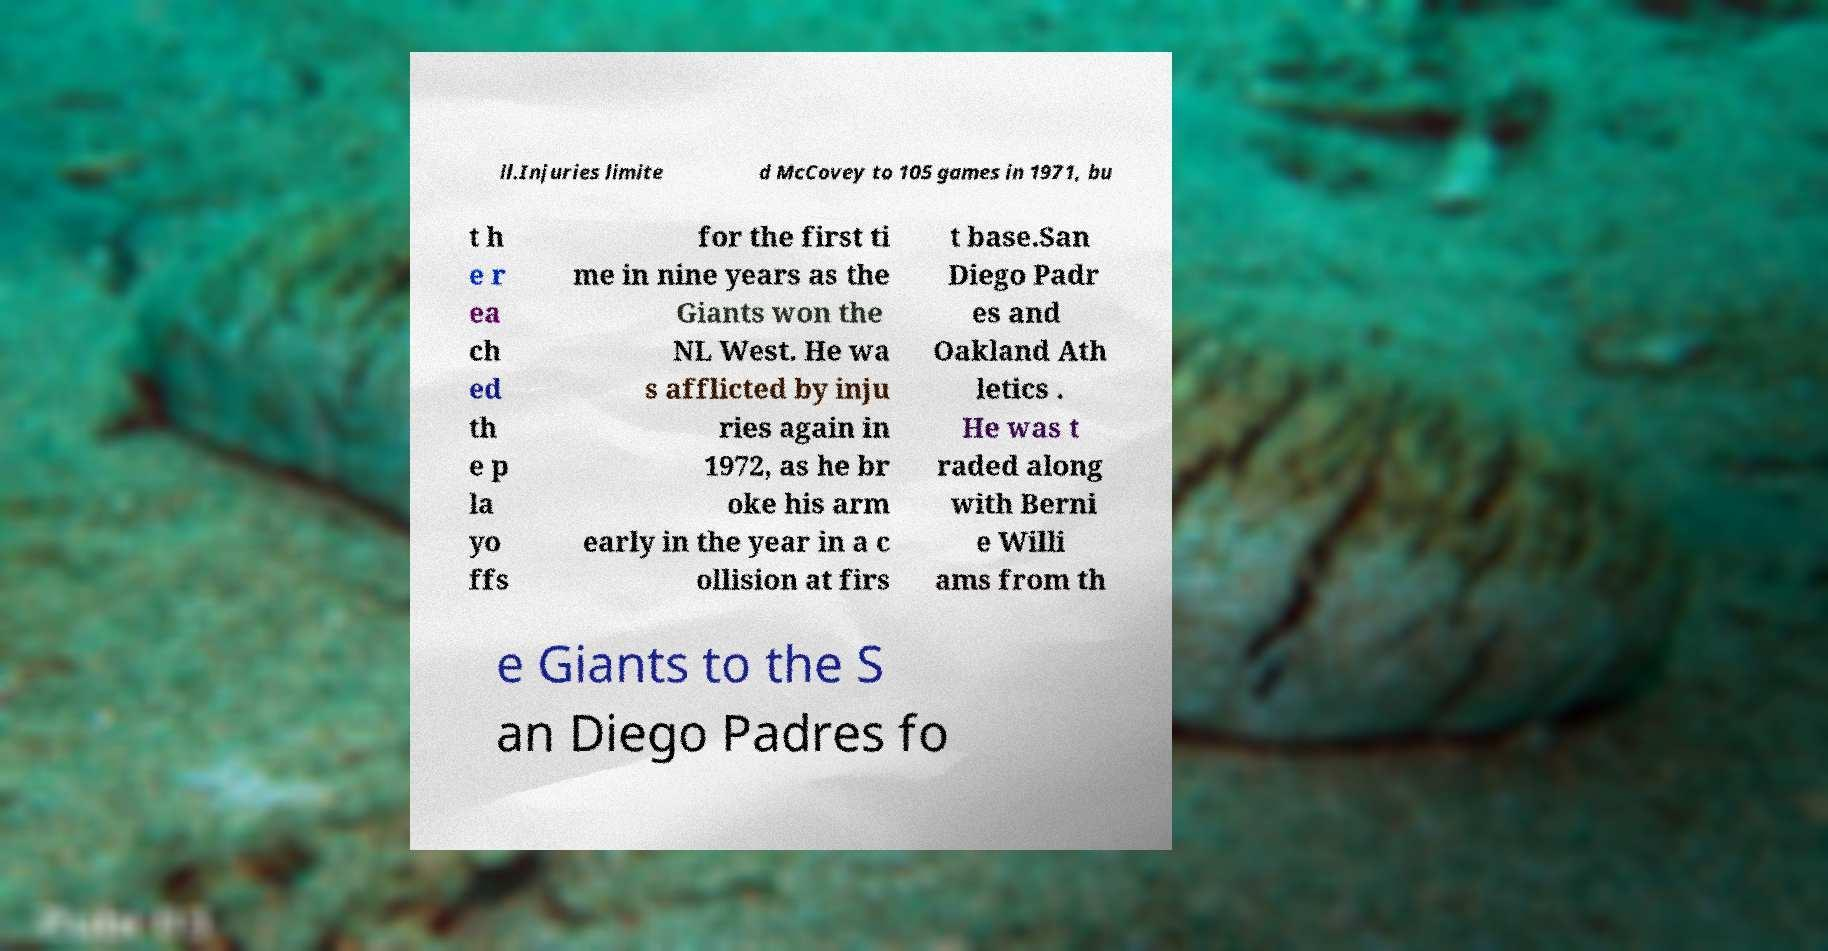What messages or text are displayed in this image? I need them in a readable, typed format. ll.Injuries limite d McCovey to 105 games in 1971, bu t h e r ea ch ed th e p la yo ffs for the first ti me in nine years as the Giants won the NL West. He wa s afflicted by inju ries again in 1972, as he br oke his arm early in the year in a c ollision at firs t base.San Diego Padr es and Oakland Ath letics . He was t raded along with Berni e Willi ams from th e Giants to the S an Diego Padres fo 